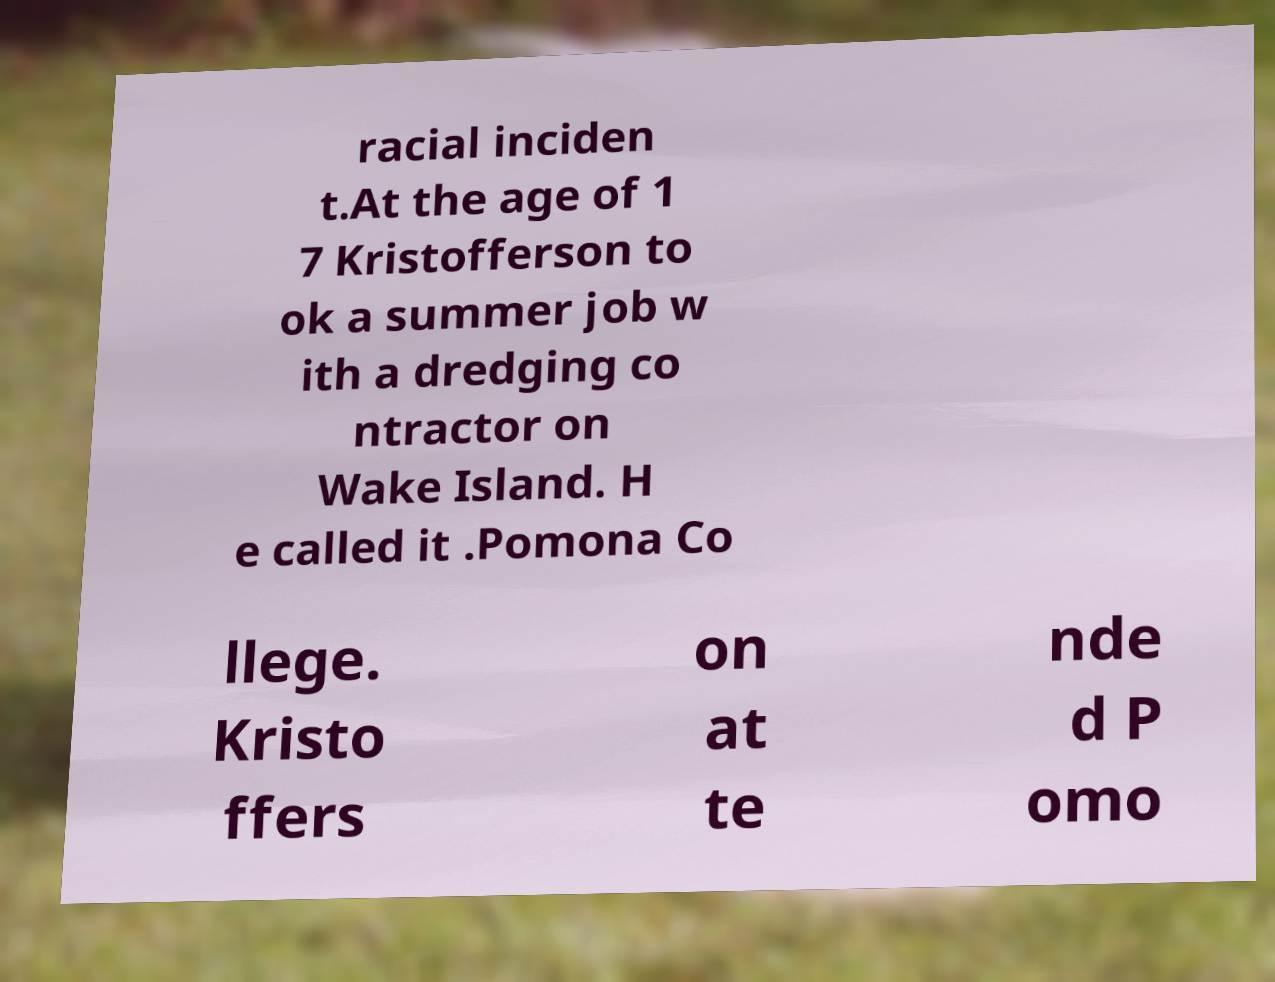I need the written content from this picture converted into text. Can you do that? racial inciden t.At the age of 1 7 Kristofferson to ok a summer job w ith a dredging co ntractor on Wake Island. H e called it .Pomona Co llege. Kristo ffers on at te nde d P omo 